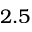Convert formula to latex. <formula><loc_0><loc_0><loc_500><loc_500>2 . 5</formula> 